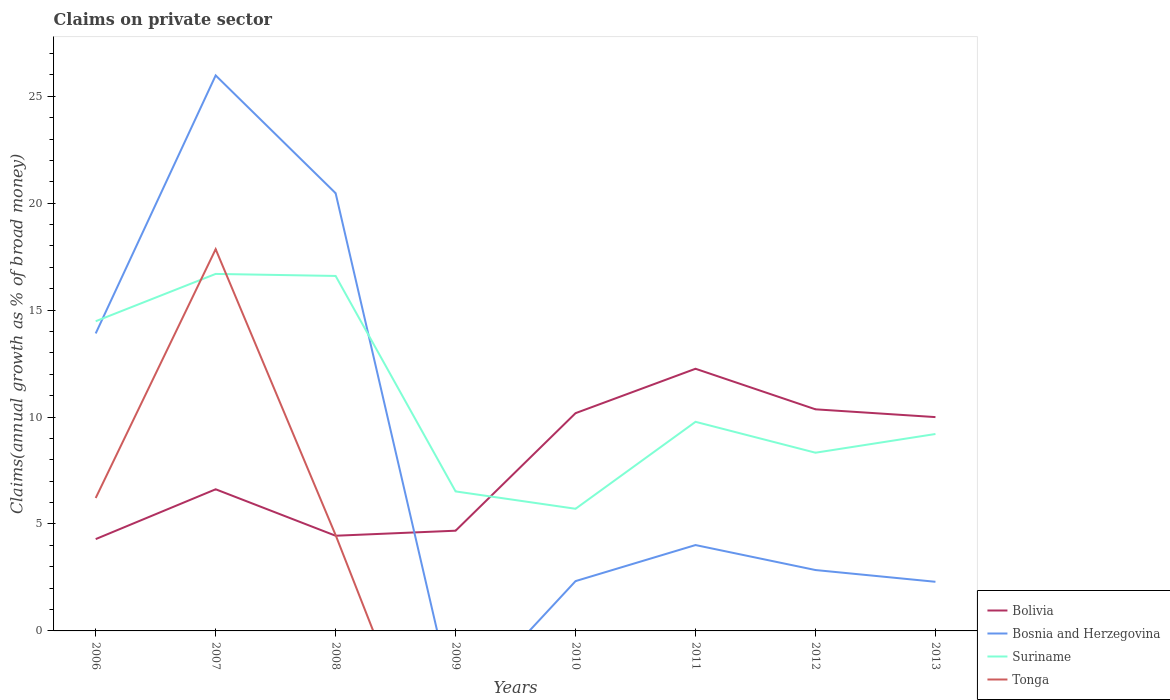How many different coloured lines are there?
Your response must be concise. 4. Is the number of lines equal to the number of legend labels?
Give a very brief answer. No. Across all years, what is the maximum percentage of broad money claimed on private sector in Tonga?
Keep it short and to the point. 0. What is the total percentage of broad money claimed on private sector in Bosnia and Herzegovina in the graph?
Give a very brief answer. 18.17. What is the difference between the highest and the second highest percentage of broad money claimed on private sector in Bosnia and Herzegovina?
Ensure brevity in your answer.  25.98. How many lines are there?
Make the answer very short. 4. Does the graph contain any zero values?
Make the answer very short. Yes. Does the graph contain grids?
Make the answer very short. No. How many legend labels are there?
Make the answer very short. 4. What is the title of the graph?
Make the answer very short. Claims on private sector. What is the label or title of the X-axis?
Offer a very short reply. Years. What is the label or title of the Y-axis?
Your answer should be compact. Claims(annual growth as % of broad money). What is the Claims(annual growth as % of broad money) in Bolivia in 2006?
Make the answer very short. 4.29. What is the Claims(annual growth as % of broad money) of Bosnia and Herzegovina in 2006?
Ensure brevity in your answer.  13.91. What is the Claims(annual growth as % of broad money) of Suriname in 2006?
Make the answer very short. 14.48. What is the Claims(annual growth as % of broad money) in Tonga in 2006?
Give a very brief answer. 6.22. What is the Claims(annual growth as % of broad money) in Bolivia in 2007?
Make the answer very short. 6.62. What is the Claims(annual growth as % of broad money) of Bosnia and Herzegovina in 2007?
Ensure brevity in your answer.  25.98. What is the Claims(annual growth as % of broad money) in Suriname in 2007?
Offer a very short reply. 16.69. What is the Claims(annual growth as % of broad money) in Tonga in 2007?
Offer a terse response. 17.85. What is the Claims(annual growth as % of broad money) in Bolivia in 2008?
Give a very brief answer. 4.45. What is the Claims(annual growth as % of broad money) in Bosnia and Herzegovina in 2008?
Give a very brief answer. 20.47. What is the Claims(annual growth as % of broad money) in Suriname in 2008?
Provide a succinct answer. 16.6. What is the Claims(annual growth as % of broad money) of Tonga in 2008?
Ensure brevity in your answer.  4.48. What is the Claims(annual growth as % of broad money) in Bolivia in 2009?
Make the answer very short. 4.69. What is the Claims(annual growth as % of broad money) of Suriname in 2009?
Give a very brief answer. 6.52. What is the Claims(annual growth as % of broad money) of Tonga in 2009?
Keep it short and to the point. 0. What is the Claims(annual growth as % of broad money) of Bolivia in 2010?
Provide a succinct answer. 10.18. What is the Claims(annual growth as % of broad money) in Bosnia and Herzegovina in 2010?
Your answer should be very brief. 2.33. What is the Claims(annual growth as % of broad money) in Suriname in 2010?
Provide a succinct answer. 5.71. What is the Claims(annual growth as % of broad money) in Tonga in 2010?
Provide a succinct answer. 0. What is the Claims(annual growth as % of broad money) in Bolivia in 2011?
Ensure brevity in your answer.  12.26. What is the Claims(annual growth as % of broad money) in Bosnia and Herzegovina in 2011?
Give a very brief answer. 4.02. What is the Claims(annual growth as % of broad money) in Suriname in 2011?
Ensure brevity in your answer.  9.78. What is the Claims(annual growth as % of broad money) in Tonga in 2011?
Provide a short and direct response. 0. What is the Claims(annual growth as % of broad money) in Bolivia in 2012?
Your response must be concise. 10.36. What is the Claims(annual growth as % of broad money) in Bosnia and Herzegovina in 2012?
Make the answer very short. 2.85. What is the Claims(annual growth as % of broad money) in Suriname in 2012?
Provide a succinct answer. 8.33. What is the Claims(annual growth as % of broad money) in Tonga in 2012?
Your response must be concise. 0. What is the Claims(annual growth as % of broad money) of Bolivia in 2013?
Your answer should be very brief. 10. What is the Claims(annual growth as % of broad money) in Bosnia and Herzegovina in 2013?
Offer a very short reply. 2.3. What is the Claims(annual growth as % of broad money) of Suriname in 2013?
Offer a very short reply. 9.21. What is the Claims(annual growth as % of broad money) in Tonga in 2013?
Keep it short and to the point. 0. Across all years, what is the maximum Claims(annual growth as % of broad money) of Bolivia?
Keep it short and to the point. 12.26. Across all years, what is the maximum Claims(annual growth as % of broad money) of Bosnia and Herzegovina?
Give a very brief answer. 25.98. Across all years, what is the maximum Claims(annual growth as % of broad money) in Suriname?
Provide a short and direct response. 16.69. Across all years, what is the maximum Claims(annual growth as % of broad money) of Tonga?
Give a very brief answer. 17.85. Across all years, what is the minimum Claims(annual growth as % of broad money) of Bolivia?
Give a very brief answer. 4.29. Across all years, what is the minimum Claims(annual growth as % of broad money) in Bosnia and Herzegovina?
Keep it short and to the point. 0. Across all years, what is the minimum Claims(annual growth as % of broad money) of Suriname?
Offer a very short reply. 5.71. Across all years, what is the minimum Claims(annual growth as % of broad money) in Tonga?
Offer a very short reply. 0. What is the total Claims(annual growth as % of broad money) of Bolivia in the graph?
Keep it short and to the point. 62.86. What is the total Claims(annual growth as % of broad money) of Bosnia and Herzegovina in the graph?
Provide a succinct answer. 71.84. What is the total Claims(annual growth as % of broad money) in Suriname in the graph?
Give a very brief answer. 87.33. What is the total Claims(annual growth as % of broad money) in Tonga in the graph?
Give a very brief answer. 28.55. What is the difference between the Claims(annual growth as % of broad money) of Bolivia in 2006 and that in 2007?
Ensure brevity in your answer.  -2.33. What is the difference between the Claims(annual growth as % of broad money) of Bosnia and Herzegovina in 2006 and that in 2007?
Offer a very short reply. -12.06. What is the difference between the Claims(annual growth as % of broad money) of Suriname in 2006 and that in 2007?
Your answer should be very brief. -2.21. What is the difference between the Claims(annual growth as % of broad money) in Tonga in 2006 and that in 2007?
Make the answer very short. -11.63. What is the difference between the Claims(annual growth as % of broad money) in Bolivia in 2006 and that in 2008?
Provide a short and direct response. -0.16. What is the difference between the Claims(annual growth as % of broad money) of Bosnia and Herzegovina in 2006 and that in 2008?
Ensure brevity in your answer.  -6.56. What is the difference between the Claims(annual growth as % of broad money) of Suriname in 2006 and that in 2008?
Keep it short and to the point. -2.12. What is the difference between the Claims(annual growth as % of broad money) in Tonga in 2006 and that in 2008?
Your response must be concise. 1.73. What is the difference between the Claims(annual growth as % of broad money) of Bolivia in 2006 and that in 2009?
Ensure brevity in your answer.  -0.39. What is the difference between the Claims(annual growth as % of broad money) in Suriname in 2006 and that in 2009?
Provide a short and direct response. 7.96. What is the difference between the Claims(annual growth as % of broad money) of Bolivia in 2006 and that in 2010?
Your response must be concise. -5.89. What is the difference between the Claims(annual growth as % of broad money) of Bosnia and Herzegovina in 2006 and that in 2010?
Ensure brevity in your answer.  11.58. What is the difference between the Claims(annual growth as % of broad money) in Suriname in 2006 and that in 2010?
Ensure brevity in your answer.  8.77. What is the difference between the Claims(annual growth as % of broad money) in Bolivia in 2006 and that in 2011?
Ensure brevity in your answer.  -7.96. What is the difference between the Claims(annual growth as % of broad money) of Bosnia and Herzegovina in 2006 and that in 2011?
Give a very brief answer. 9.9. What is the difference between the Claims(annual growth as % of broad money) of Suriname in 2006 and that in 2011?
Ensure brevity in your answer.  4.7. What is the difference between the Claims(annual growth as % of broad money) in Bolivia in 2006 and that in 2012?
Ensure brevity in your answer.  -6.07. What is the difference between the Claims(annual growth as % of broad money) in Bosnia and Herzegovina in 2006 and that in 2012?
Give a very brief answer. 11.06. What is the difference between the Claims(annual growth as % of broad money) in Suriname in 2006 and that in 2012?
Make the answer very short. 6.15. What is the difference between the Claims(annual growth as % of broad money) in Bolivia in 2006 and that in 2013?
Your answer should be compact. -5.7. What is the difference between the Claims(annual growth as % of broad money) of Bosnia and Herzegovina in 2006 and that in 2013?
Your answer should be compact. 11.61. What is the difference between the Claims(annual growth as % of broad money) in Suriname in 2006 and that in 2013?
Your answer should be very brief. 5.27. What is the difference between the Claims(annual growth as % of broad money) in Bolivia in 2007 and that in 2008?
Your response must be concise. 2.17. What is the difference between the Claims(annual growth as % of broad money) of Bosnia and Herzegovina in 2007 and that in 2008?
Your answer should be compact. 5.51. What is the difference between the Claims(annual growth as % of broad money) of Suriname in 2007 and that in 2008?
Your response must be concise. 0.1. What is the difference between the Claims(annual growth as % of broad money) in Tonga in 2007 and that in 2008?
Offer a very short reply. 13.37. What is the difference between the Claims(annual growth as % of broad money) in Bolivia in 2007 and that in 2009?
Your response must be concise. 1.94. What is the difference between the Claims(annual growth as % of broad money) of Suriname in 2007 and that in 2009?
Give a very brief answer. 10.17. What is the difference between the Claims(annual growth as % of broad money) of Bolivia in 2007 and that in 2010?
Provide a short and direct response. -3.56. What is the difference between the Claims(annual growth as % of broad money) of Bosnia and Herzegovina in 2007 and that in 2010?
Provide a short and direct response. 23.65. What is the difference between the Claims(annual growth as % of broad money) of Suriname in 2007 and that in 2010?
Your answer should be compact. 10.98. What is the difference between the Claims(annual growth as % of broad money) in Bolivia in 2007 and that in 2011?
Make the answer very short. -5.64. What is the difference between the Claims(annual growth as % of broad money) of Bosnia and Herzegovina in 2007 and that in 2011?
Ensure brevity in your answer.  21.96. What is the difference between the Claims(annual growth as % of broad money) in Suriname in 2007 and that in 2011?
Keep it short and to the point. 6.92. What is the difference between the Claims(annual growth as % of broad money) of Bolivia in 2007 and that in 2012?
Offer a terse response. -3.74. What is the difference between the Claims(annual growth as % of broad money) of Bosnia and Herzegovina in 2007 and that in 2012?
Offer a terse response. 23.13. What is the difference between the Claims(annual growth as % of broad money) of Suriname in 2007 and that in 2012?
Provide a short and direct response. 8.36. What is the difference between the Claims(annual growth as % of broad money) in Bolivia in 2007 and that in 2013?
Your response must be concise. -3.38. What is the difference between the Claims(annual growth as % of broad money) in Bosnia and Herzegovina in 2007 and that in 2013?
Keep it short and to the point. 23.68. What is the difference between the Claims(annual growth as % of broad money) in Suriname in 2007 and that in 2013?
Make the answer very short. 7.49. What is the difference between the Claims(annual growth as % of broad money) of Bolivia in 2008 and that in 2009?
Keep it short and to the point. -0.24. What is the difference between the Claims(annual growth as % of broad money) in Suriname in 2008 and that in 2009?
Offer a very short reply. 10.08. What is the difference between the Claims(annual growth as % of broad money) of Bolivia in 2008 and that in 2010?
Ensure brevity in your answer.  -5.73. What is the difference between the Claims(annual growth as % of broad money) in Bosnia and Herzegovina in 2008 and that in 2010?
Provide a short and direct response. 18.14. What is the difference between the Claims(annual growth as % of broad money) in Suriname in 2008 and that in 2010?
Provide a succinct answer. 10.89. What is the difference between the Claims(annual growth as % of broad money) in Bolivia in 2008 and that in 2011?
Your answer should be compact. -7.81. What is the difference between the Claims(annual growth as % of broad money) of Bosnia and Herzegovina in 2008 and that in 2011?
Provide a short and direct response. 16.45. What is the difference between the Claims(annual growth as % of broad money) of Suriname in 2008 and that in 2011?
Give a very brief answer. 6.82. What is the difference between the Claims(annual growth as % of broad money) in Bolivia in 2008 and that in 2012?
Your response must be concise. -5.91. What is the difference between the Claims(annual growth as % of broad money) of Bosnia and Herzegovina in 2008 and that in 2012?
Ensure brevity in your answer.  17.62. What is the difference between the Claims(annual growth as % of broad money) of Suriname in 2008 and that in 2012?
Offer a terse response. 8.27. What is the difference between the Claims(annual growth as % of broad money) in Bolivia in 2008 and that in 2013?
Provide a short and direct response. -5.55. What is the difference between the Claims(annual growth as % of broad money) of Bosnia and Herzegovina in 2008 and that in 2013?
Keep it short and to the point. 18.17. What is the difference between the Claims(annual growth as % of broad money) of Suriname in 2008 and that in 2013?
Provide a succinct answer. 7.39. What is the difference between the Claims(annual growth as % of broad money) of Bolivia in 2009 and that in 2010?
Ensure brevity in your answer.  -5.5. What is the difference between the Claims(annual growth as % of broad money) of Suriname in 2009 and that in 2010?
Keep it short and to the point. 0.81. What is the difference between the Claims(annual growth as % of broad money) of Bolivia in 2009 and that in 2011?
Offer a terse response. -7.57. What is the difference between the Claims(annual growth as % of broad money) of Suriname in 2009 and that in 2011?
Your answer should be very brief. -3.25. What is the difference between the Claims(annual growth as % of broad money) of Bolivia in 2009 and that in 2012?
Your response must be concise. -5.68. What is the difference between the Claims(annual growth as % of broad money) of Suriname in 2009 and that in 2012?
Give a very brief answer. -1.81. What is the difference between the Claims(annual growth as % of broad money) in Bolivia in 2009 and that in 2013?
Your response must be concise. -5.31. What is the difference between the Claims(annual growth as % of broad money) of Suriname in 2009 and that in 2013?
Your response must be concise. -2.68. What is the difference between the Claims(annual growth as % of broad money) of Bolivia in 2010 and that in 2011?
Make the answer very short. -2.08. What is the difference between the Claims(annual growth as % of broad money) of Bosnia and Herzegovina in 2010 and that in 2011?
Provide a succinct answer. -1.69. What is the difference between the Claims(annual growth as % of broad money) in Suriname in 2010 and that in 2011?
Give a very brief answer. -4.07. What is the difference between the Claims(annual growth as % of broad money) of Bolivia in 2010 and that in 2012?
Provide a short and direct response. -0.18. What is the difference between the Claims(annual growth as % of broad money) in Bosnia and Herzegovina in 2010 and that in 2012?
Ensure brevity in your answer.  -0.52. What is the difference between the Claims(annual growth as % of broad money) in Suriname in 2010 and that in 2012?
Provide a succinct answer. -2.62. What is the difference between the Claims(annual growth as % of broad money) of Bolivia in 2010 and that in 2013?
Provide a succinct answer. 0.18. What is the difference between the Claims(annual growth as % of broad money) in Bosnia and Herzegovina in 2010 and that in 2013?
Give a very brief answer. 0.03. What is the difference between the Claims(annual growth as % of broad money) of Suriname in 2010 and that in 2013?
Offer a terse response. -3.5. What is the difference between the Claims(annual growth as % of broad money) of Bolivia in 2011 and that in 2012?
Your response must be concise. 1.9. What is the difference between the Claims(annual growth as % of broad money) of Bosnia and Herzegovina in 2011 and that in 2012?
Give a very brief answer. 1.17. What is the difference between the Claims(annual growth as % of broad money) of Suriname in 2011 and that in 2012?
Your answer should be very brief. 1.44. What is the difference between the Claims(annual growth as % of broad money) of Bolivia in 2011 and that in 2013?
Provide a short and direct response. 2.26. What is the difference between the Claims(annual growth as % of broad money) of Bosnia and Herzegovina in 2011 and that in 2013?
Provide a succinct answer. 1.72. What is the difference between the Claims(annual growth as % of broad money) of Suriname in 2011 and that in 2013?
Your answer should be very brief. 0.57. What is the difference between the Claims(annual growth as % of broad money) in Bolivia in 2012 and that in 2013?
Keep it short and to the point. 0.36. What is the difference between the Claims(annual growth as % of broad money) in Bosnia and Herzegovina in 2012 and that in 2013?
Make the answer very short. 0.55. What is the difference between the Claims(annual growth as % of broad money) of Suriname in 2012 and that in 2013?
Provide a succinct answer. -0.87. What is the difference between the Claims(annual growth as % of broad money) of Bolivia in 2006 and the Claims(annual growth as % of broad money) of Bosnia and Herzegovina in 2007?
Provide a short and direct response. -21.68. What is the difference between the Claims(annual growth as % of broad money) of Bolivia in 2006 and the Claims(annual growth as % of broad money) of Suriname in 2007?
Your answer should be very brief. -12.4. What is the difference between the Claims(annual growth as % of broad money) of Bolivia in 2006 and the Claims(annual growth as % of broad money) of Tonga in 2007?
Provide a short and direct response. -13.56. What is the difference between the Claims(annual growth as % of broad money) in Bosnia and Herzegovina in 2006 and the Claims(annual growth as % of broad money) in Suriname in 2007?
Keep it short and to the point. -2.78. What is the difference between the Claims(annual growth as % of broad money) of Bosnia and Herzegovina in 2006 and the Claims(annual growth as % of broad money) of Tonga in 2007?
Ensure brevity in your answer.  -3.94. What is the difference between the Claims(annual growth as % of broad money) in Suriname in 2006 and the Claims(annual growth as % of broad money) in Tonga in 2007?
Keep it short and to the point. -3.37. What is the difference between the Claims(annual growth as % of broad money) in Bolivia in 2006 and the Claims(annual growth as % of broad money) in Bosnia and Herzegovina in 2008?
Provide a short and direct response. -16.17. What is the difference between the Claims(annual growth as % of broad money) of Bolivia in 2006 and the Claims(annual growth as % of broad money) of Suriname in 2008?
Provide a short and direct response. -12.3. What is the difference between the Claims(annual growth as % of broad money) of Bolivia in 2006 and the Claims(annual growth as % of broad money) of Tonga in 2008?
Keep it short and to the point. -0.19. What is the difference between the Claims(annual growth as % of broad money) in Bosnia and Herzegovina in 2006 and the Claims(annual growth as % of broad money) in Suriname in 2008?
Provide a succinct answer. -2.69. What is the difference between the Claims(annual growth as % of broad money) of Bosnia and Herzegovina in 2006 and the Claims(annual growth as % of broad money) of Tonga in 2008?
Your answer should be compact. 9.43. What is the difference between the Claims(annual growth as % of broad money) in Suriname in 2006 and the Claims(annual growth as % of broad money) in Tonga in 2008?
Provide a succinct answer. 10. What is the difference between the Claims(annual growth as % of broad money) of Bolivia in 2006 and the Claims(annual growth as % of broad money) of Suriname in 2009?
Keep it short and to the point. -2.23. What is the difference between the Claims(annual growth as % of broad money) in Bosnia and Herzegovina in 2006 and the Claims(annual growth as % of broad money) in Suriname in 2009?
Make the answer very short. 7.39. What is the difference between the Claims(annual growth as % of broad money) in Bolivia in 2006 and the Claims(annual growth as % of broad money) in Bosnia and Herzegovina in 2010?
Provide a succinct answer. 1.96. What is the difference between the Claims(annual growth as % of broad money) in Bolivia in 2006 and the Claims(annual growth as % of broad money) in Suriname in 2010?
Offer a very short reply. -1.42. What is the difference between the Claims(annual growth as % of broad money) of Bosnia and Herzegovina in 2006 and the Claims(annual growth as % of broad money) of Suriname in 2010?
Ensure brevity in your answer.  8.2. What is the difference between the Claims(annual growth as % of broad money) in Bolivia in 2006 and the Claims(annual growth as % of broad money) in Bosnia and Herzegovina in 2011?
Ensure brevity in your answer.  0.28. What is the difference between the Claims(annual growth as % of broad money) of Bolivia in 2006 and the Claims(annual growth as % of broad money) of Suriname in 2011?
Provide a short and direct response. -5.48. What is the difference between the Claims(annual growth as % of broad money) in Bosnia and Herzegovina in 2006 and the Claims(annual growth as % of broad money) in Suriname in 2011?
Ensure brevity in your answer.  4.13. What is the difference between the Claims(annual growth as % of broad money) of Bolivia in 2006 and the Claims(annual growth as % of broad money) of Bosnia and Herzegovina in 2012?
Ensure brevity in your answer.  1.45. What is the difference between the Claims(annual growth as % of broad money) of Bolivia in 2006 and the Claims(annual growth as % of broad money) of Suriname in 2012?
Give a very brief answer. -4.04. What is the difference between the Claims(annual growth as % of broad money) in Bosnia and Herzegovina in 2006 and the Claims(annual growth as % of broad money) in Suriname in 2012?
Give a very brief answer. 5.58. What is the difference between the Claims(annual growth as % of broad money) of Bolivia in 2006 and the Claims(annual growth as % of broad money) of Bosnia and Herzegovina in 2013?
Offer a terse response. 2. What is the difference between the Claims(annual growth as % of broad money) of Bolivia in 2006 and the Claims(annual growth as % of broad money) of Suriname in 2013?
Your answer should be compact. -4.91. What is the difference between the Claims(annual growth as % of broad money) in Bosnia and Herzegovina in 2006 and the Claims(annual growth as % of broad money) in Suriname in 2013?
Ensure brevity in your answer.  4.7. What is the difference between the Claims(annual growth as % of broad money) of Bolivia in 2007 and the Claims(annual growth as % of broad money) of Bosnia and Herzegovina in 2008?
Offer a very short reply. -13.84. What is the difference between the Claims(annual growth as % of broad money) in Bolivia in 2007 and the Claims(annual growth as % of broad money) in Suriname in 2008?
Your answer should be compact. -9.98. What is the difference between the Claims(annual growth as % of broad money) of Bolivia in 2007 and the Claims(annual growth as % of broad money) of Tonga in 2008?
Offer a terse response. 2.14. What is the difference between the Claims(annual growth as % of broad money) in Bosnia and Herzegovina in 2007 and the Claims(annual growth as % of broad money) in Suriname in 2008?
Your response must be concise. 9.38. What is the difference between the Claims(annual growth as % of broad money) of Bosnia and Herzegovina in 2007 and the Claims(annual growth as % of broad money) of Tonga in 2008?
Provide a succinct answer. 21.49. What is the difference between the Claims(annual growth as % of broad money) in Suriname in 2007 and the Claims(annual growth as % of broad money) in Tonga in 2008?
Give a very brief answer. 12.21. What is the difference between the Claims(annual growth as % of broad money) of Bolivia in 2007 and the Claims(annual growth as % of broad money) of Suriname in 2009?
Ensure brevity in your answer.  0.1. What is the difference between the Claims(annual growth as % of broad money) of Bosnia and Herzegovina in 2007 and the Claims(annual growth as % of broad money) of Suriname in 2009?
Your answer should be compact. 19.45. What is the difference between the Claims(annual growth as % of broad money) in Bolivia in 2007 and the Claims(annual growth as % of broad money) in Bosnia and Herzegovina in 2010?
Offer a very short reply. 4.29. What is the difference between the Claims(annual growth as % of broad money) of Bolivia in 2007 and the Claims(annual growth as % of broad money) of Suriname in 2010?
Provide a succinct answer. 0.91. What is the difference between the Claims(annual growth as % of broad money) of Bosnia and Herzegovina in 2007 and the Claims(annual growth as % of broad money) of Suriname in 2010?
Offer a very short reply. 20.26. What is the difference between the Claims(annual growth as % of broad money) in Bolivia in 2007 and the Claims(annual growth as % of broad money) in Bosnia and Herzegovina in 2011?
Provide a short and direct response. 2.61. What is the difference between the Claims(annual growth as % of broad money) of Bolivia in 2007 and the Claims(annual growth as % of broad money) of Suriname in 2011?
Make the answer very short. -3.15. What is the difference between the Claims(annual growth as % of broad money) in Bosnia and Herzegovina in 2007 and the Claims(annual growth as % of broad money) in Suriname in 2011?
Ensure brevity in your answer.  16.2. What is the difference between the Claims(annual growth as % of broad money) of Bolivia in 2007 and the Claims(annual growth as % of broad money) of Bosnia and Herzegovina in 2012?
Provide a succinct answer. 3.78. What is the difference between the Claims(annual growth as % of broad money) of Bolivia in 2007 and the Claims(annual growth as % of broad money) of Suriname in 2012?
Your answer should be very brief. -1.71. What is the difference between the Claims(annual growth as % of broad money) of Bosnia and Herzegovina in 2007 and the Claims(annual growth as % of broad money) of Suriname in 2012?
Your answer should be very brief. 17.64. What is the difference between the Claims(annual growth as % of broad money) of Bolivia in 2007 and the Claims(annual growth as % of broad money) of Bosnia and Herzegovina in 2013?
Provide a succinct answer. 4.33. What is the difference between the Claims(annual growth as % of broad money) of Bolivia in 2007 and the Claims(annual growth as % of broad money) of Suriname in 2013?
Your response must be concise. -2.58. What is the difference between the Claims(annual growth as % of broad money) in Bosnia and Herzegovina in 2007 and the Claims(annual growth as % of broad money) in Suriname in 2013?
Make the answer very short. 16.77. What is the difference between the Claims(annual growth as % of broad money) in Bolivia in 2008 and the Claims(annual growth as % of broad money) in Suriname in 2009?
Keep it short and to the point. -2.07. What is the difference between the Claims(annual growth as % of broad money) in Bosnia and Herzegovina in 2008 and the Claims(annual growth as % of broad money) in Suriname in 2009?
Keep it short and to the point. 13.94. What is the difference between the Claims(annual growth as % of broad money) of Bolivia in 2008 and the Claims(annual growth as % of broad money) of Bosnia and Herzegovina in 2010?
Keep it short and to the point. 2.12. What is the difference between the Claims(annual growth as % of broad money) in Bolivia in 2008 and the Claims(annual growth as % of broad money) in Suriname in 2010?
Offer a terse response. -1.26. What is the difference between the Claims(annual growth as % of broad money) of Bosnia and Herzegovina in 2008 and the Claims(annual growth as % of broad money) of Suriname in 2010?
Ensure brevity in your answer.  14.76. What is the difference between the Claims(annual growth as % of broad money) in Bolivia in 2008 and the Claims(annual growth as % of broad money) in Bosnia and Herzegovina in 2011?
Your response must be concise. 0.44. What is the difference between the Claims(annual growth as % of broad money) in Bolivia in 2008 and the Claims(annual growth as % of broad money) in Suriname in 2011?
Make the answer very short. -5.33. What is the difference between the Claims(annual growth as % of broad money) of Bosnia and Herzegovina in 2008 and the Claims(annual growth as % of broad money) of Suriname in 2011?
Ensure brevity in your answer.  10.69. What is the difference between the Claims(annual growth as % of broad money) in Bolivia in 2008 and the Claims(annual growth as % of broad money) in Bosnia and Herzegovina in 2012?
Make the answer very short. 1.6. What is the difference between the Claims(annual growth as % of broad money) in Bolivia in 2008 and the Claims(annual growth as % of broad money) in Suriname in 2012?
Offer a very short reply. -3.88. What is the difference between the Claims(annual growth as % of broad money) of Bosnia and Herzegovina in 2008 and the Claims(annual growth as % of broad money) of Suriname in 2012?
Make the answer very short. 12.13. What is the difference between the Claims(annual growth as % of broad money) of Bolivia in 2008 and the Claims(annual growth as % of broad money) of Bosnia and Herzegovina in 2013?
Provide a succinct answer. 2.15. What is the difference between the Claims(annual growth as % of broad money) in Bolivia in 2008 and the Claims(annual growth as % of broad money) in Suriname in 2013?
Your response must be concise. -4.76. What is the difference between the Claims(annual growth as % of broad money) in Bosnia and Herzegovina in 2008 and the Claims(annual growth as % of broad money) in Suriname in 2013?
Your answer should be compact. 11.26. What is the difference between the Claims(annual growth as % of broad money) of Bolivia in 2009 and the Claims(annual growth as % of broad money) of Bosnia and Herzegovina in 2010?
Offer a very short reply. 2.36. What is the difference between the Claims(annual growth as % of broad money) in Bolivia in 2009 and the Claims(annual growth as % of broad money) in Suriname in 2010?
Give a very brief answer. -1.03. What is the difference between the Claims(annual growth as % of broad money) of Bolivia in 2009 and the Claims(annual growth as % of broad money) of Bosnia and Herzegovina in 2011?
Give a very brief answer. 0.67. What is the difference between the Claims(annual growth as % of broad money) in Bolivia in 2009 and the Claims(annual growth as % of broad money) in Suriname in 2011?
Give a very brief answer. -5.09. What is the difference between the Claims(annual growth as % of broad money) of Bolivia in 2009 and the Claims(annual growth as % of broad money) of Bosnia and Herzegovina in 2012?
Provide a succinct answer. 1.84. What is the difference between the Claims(annual growth as % of broad money) of Bolivia in 2009 and the Claims(annual growth as % of broad money) of Suriname in 2012?
Make the answer very short. -3.65. What is the difference between the Claims(annual growth as % of broad money) in Bolivia in 2009 and the Claims(annual growth as % of broad money) in Bosnia and Herzegovina in 2013?
Provide a short and direct response. 2.39. What is the difference between the Claims(annual growth as % of broad money) in Bolivia in 2009 and the Claims(annual growth as % of broad money) in Suriname in 2013?
Provide a short and direct response. -4.52. What is the difference between the Claims(annual growth as % of broad money) in Bolivia in 2010 and the Claims(annual growth as % of broad money) in Bosnia and Herzegovina in 2011?
Provide a short and direct response. 6.17. What is the difference between the Claims(annual growth as % of broad money) of Bolivia in 2010 and the Claims(annual growth as % of broad money) of Suriname in 2011?
Your response must be concise. 0.4. What is the difference between the Claims(annual growth as % of broad money) of Bosnia and Herzegovina in 2010 and the Claims(annual growth as % of broad money) of Suriname in 2011?
Provide a succinct answer. -7.45. What is the difference between the Claims(annual growth as % of broad money) of Bolivia in 2010 and the Claims(annual growth as % of broad money) of Bosnia and Herzegovina in 2012?
Offer a very short reply. 7.34. What is the difference between the Claims(annual growth as % of broad money) of Bolivia in 2010 and the Claims(annual growth as % of broad money) of Suriname in 2012?
Keep it short and to the point. 1.85. What is the difference between the Claims(annual growth as % of broad money) in Bosnia and Herzegovina in 2010 and the Claims(annual growth as % of broad money) in Suriname in 2012?
Offer a very short reply. -6. What is the difference between the Claims(annual growth as % of broad money) of Bolivia in 2010 and the Claims(annual growth as % of broad money) of Bosnia and Herzegovina in 2013?
Your response must be concise. 7.89. What is the difference between the Claims(annual growth as % of broad money) of Bolivia in 2010 and the Claims(annual growth as % of broad money) of Suriname in 2013?
Keep it short and to the point. 0.97. What is the difference between the Claims(annual growth as % of broad money) of Bosnia and Herzegovina in 2010 and the Claims(annual growth as % of broad money) of Suriname in 2013?
Offer a terse response. -6.88. What is the difference between the Claims(annual growth as % of broad money) of Bolivia in 2011 and the Claims(annual growth as % of broad money) of Bosnia and Herzegovina in 2012?
Your answer should be compact. 9.41. What is the difference between the Claims(annual growth as % of broad money) in Bolivia in 2011 and the Claims(annual growth as % of broad money) in Suriname in 2012?
Your response must be concise. 3.93. What is the difference between the Claims(annual growth as % of broad money) of Bosnia and Herzegovina in 2011 and the Claims(annual growth as % of broad money) of Suriname in 2012?
Provide a succinct answer. -4.32. What is the difference between the Claims(annual growth as % of broad money) in Bolivia in 2011 and the Claims(annual growth as % of broad money) in Bosnia and Herzegovina in 2013?
Keep it short and to the point. 9.96. What is the difference between the Claims(annual growth as % of broad money) of Bolivia in 2011 and the Claims(annual growth as % of broad money) of Suriname in 2013?
Your answer should be very brief. 3.05. What is the difference between the Claims(annual growth as % of broad money) in Bosnia and Herzegovina in 2011 and the Claims(annual growth as % of broad money) in Suriname in 2013?
Offer a terse response. -5.19. What is the difference between the Claims(annual growth as % of broad money) of Bolivia in 2012 and the Claims(annual growth as % of broad money) of Bosnia and Herzegovina in 2013?
Offer a very short reply. 8.06. What is the difference between the Claims(annual growth as % of broad money) of Bolivia in 2012 and the Claims(annual growth as % of broad money) of Suriname in 2013?
Offer a very short reply. 1.15. What is the difference between the Claims(annual growth as % of broad money) in Bosnia and Herzegovina in 2012 and the Claims(annual growth as % of broad money) in Suriname in 2013?
Make the answer very short. -6.36. What is the average Claims(annual growth as % of broad money) of Bolivia per year?
Your answer should be compact. 7.86. What is the average Claims(annual growth as % of broad money) of Bosnia and Herzegovina per year?
Make the answer very short. 8.98. What is the average Claims(annual growth as % of broad money) of Suriname per year?
Give a very brief answer. 10.92. What is the average Claims(annual growth as % of broad money) of Tonga per year?
Keep it short and to the point. 3.57. In the year 2006, what is the difference between the Claims(annual growth as % of broad money) of Bolivia and Claims(annual growth as % of broad money) of Bosnia and Herzegovina?
Provide a short and direct response. -9.62. In the year 2006, what is the difference between the Claims(annual growth as % of broad money) in Bolivia and Claims(annual growth as % of broad money) in Suriname?
Offer a very short reply. -10.19. In the year 2006, what is the difference between the Claims(annual growth as % of broad money) in Bolivia and Claims(annual growth as % of broad money) in Tonga?
Keep it short and to the point. -1.92. In the year 2006, what is the difference between the Claims(annual growth as % of broad money) in Bosnia and Herzegovina and Claims(annual growth as % of broad money) in Suriname?
Provide a short and direct response. -0.57. In the year 2006, what is the difference between the Claims(annual growth as % of broad money) of Bosnia and Herzegovina and Claims(annual growth as % of broad money) of Tonga?
Give a very brief answer. 7.7. In the year 2006, what is the difference between the Claims(annual growth as % of broad money) in Suriname and Claims(annual growth as % of broad money) in Tonga?
Keep it short and to the point. 8.27. In the year 2007, what is the difference between the Claims(annual growth as % of broad money) of Bolivia and Claims(annual growth as % of broad money) of Bosnia and Herzegovina?
Ensure brevity in your answer.  -19.35. In the year 2007, what is the difference between the Claims(annual growth as % of broad money) in Bolivia and Claims(annual growth as % of broad money) in Suriname?
Offer a terse response. -10.07. In the year 2007, what is the difference between the Claims(annual growth as % of broad money) in Bolivia and Claims(annual growth as % of broad money) in Tonga?
Your response must be concise. -11.23. In the year 2007, what is the difference between the Claims(annual growth as % of broad money) of Bosnia and Herzegovina and Claims(annual growth as % of broad money) of Suriname?
Offer a terse response. 9.28. In the year 2007, what is the difference between the Claims(annual growth as % of broad money) in Bosnia and Herzegovina and Claims(annual growth as % of broad money) in Tonga?
Your answer should be very brief. 8.13. In the year 2007, what is the difference between the Claims(annual growth as % of broad money) of Suriname and Claims(annual growth as % of broad money) of Tonga?
Provide a succinct answer. -1.16. In the year 2008, what is the difference between the Claims(annual growth as % of broad money) in Bolivia and Claims(annual growth as % of broad money) in Bosnia and Herzegovina?
Provide a succinct answer. -16.02. In the year 2008, what is the difference between the Claims(annual growth as % of broad money) in Bolivia and Claims(annual growth as % of broad money) in Suriname?
Make the answer very short. -12.15. In the year 2008, what is the difference between the Claims(annual growth as % of broad money) in Bolivia and Claims(annual growth as % of broad money) in Tonga?
Make the answer very short. -0.03. In the year 2008, what is the difference between the Claims(annual growth as % of broad money) in Bosnia and Herzegovina and Claims(annual growth as % of broad money) in Suriname?
Make the answer very short. 3.87. In the year 2008, what is the difference between the Claims(annual growth as % of broad money) in Bosnia and Herzegovina and Claims(annual growth as % of broad money) in Tonga?
Offer a very short reply. 15.99. In the year 2008, what is the difference between the Claims(annual growth as % of broad money) in Suriname and Claims(annual growth as % of broad money) in Tonga?
Your answer should be very brief. 12.12. In the year 2009, what is the difference between the Claims(annual growth as % of broad money) in Bolivia and Claims(annual growth as % of broad money) in Suriname?
Make the answer very short. -1.84. In the year 2010, what is the difference between the Claims(annual growth as % of broad money) of Bolivia and Claims(annual growth as % of broad money) of Bosnia and Herzegovina?
Give a very brief answer. 7.85. In the year 2010, what is the difference between the Claims(annual growth as % of broad money) of Bolivia and Claims(annual growth as % of broad money) of Suriname?
Keep it short and to the point. 4.47. In the year 2010, what is the difference between the Claims(annual growth as % of broad money) in Bosnia and Herzegovina and Claims(annual growth as % of broad money) in Suriname?
Offer a terse response. -3.38. In the year 2011, what is the difference between the Claims(annual growth as % of broad money) of Bolivia and Claims(annual growth as % of broad money) of Bosnia and Herzegovina?
Your answer should be very brief. 8.24. In the year 2011, what is the difference between the Claims(annual growth as % of broad money) in Bolivia and Claims(annual growth as % of broad money) in Suriname?
Provide a short and direct response. 2.48. In the year 2011, what is the difference between the Claims(annual growth as % of broad money) of Bosnia and Herzegovina and Claims(annual growth as % of broad money) of Suriname?
Offer a very short reply. -5.76. In the year 2012, what is the difference between the Claims(annual growth as % of broad money) in Bolivia and Claims(annual growth as % of broad money) in Bosnia and Herzegovina?
Your answer should be very brief. 7.52. In the year 2012, what is the difference between the Claims(annual growth as % of broad money) in Bolivia and Claims(annual growth as % of broad money) in Suriname?
Your response must be concise. 2.03. In the year 2012, what is the difference between the Claims(annual growth as % of broad money) of Bosnia and Herzegovina and Claims(annual growth as % of broad money) of Suriname?
Offer a very short reply. -5.49. In the year 2013, what is the difference between the Claims(annual growth as % of broad money) in Bolivia and Claims(annual growth as % of broad money) in Bosnia and Herzegovina?
Offer a terse response. 7.7. In the year 2013, what is the difference between the Claims(annual growth as % of broad money) in Bolivia and Claims(annual growth as % of broad money) in Suriname?
Provide a succinct answer. 0.79. In the year 2013, what is the difference between the Claims(annual growth as % of broad money) of Bosnia and Herzegovina and Claims(annual growth as % of broad money) of Suriname?
Make the answer very short. -6.91. What is the ratio of the Claims(annual growth as % of broad money) of Bolivia in 2006 to that in 2007?
Keep it short and to the point. 0.65. What is the ratio of the Claims(annual growth as % of broad money) in Bosnia and Herzegovina in 2006 to that in 2007?
Give a very brief answer. 0.54. What is the ratio of the Claims(annual growth as % of broad money) of Suriname in 2006 to that in 2007?
Give a very brief answer. 0.87. What is the ratio of the Claims(annual growth as % of broad money) in Tonga in 2006 to that in 2007?
Provide a succinct answer. 0.35. What is the ratio of the Claims(annual growth as % of broad money) of Bolivia in 2006 to that in 2008?
Ensure brevity in your answer.  0.96. What is the ratio of the Claims(annual growth as % of broad money) of Bosnia and Herzegovina in 2006 to that in 2008?
Keep it short and to the point. 0.68. What is the ratio of the Claims(annual growth as % of broad money) of Suriname in 2006 to that in 2008?
Offer a very short reply. 0.87. What is the ratio of the Claims(annual growth as % of broad money) in Tonga in 2006 to that in 2008?
Your response must be concise. 1.39. What is the ratio of the Claims(annual growth as % of broad money) of Bolivia in 2006 to that in 2009?
Keep it short and to the point. 0.92. What is the ratio of the Claims(annual growth as % of broad money) of Suriname in 2006 to that in 2009?
Your answer should be very brief. 2.22. What is the ratio of the Claims(annual growth as % of broad money) in Bolivia in 2006 to that in 2010?
Make the answer very short. 0.42. What is the ratio of the Claims(annual growth as % of broad money) in Bosnia and Herzegovina in 2006 to that in 2010?
Keep it short and to the point. 5.97. What is the ratio of the Claims(annual growth as % of broad money) in Suriname in 2006 to that in 2010?
Provide a succinct answer. 2.54. What is the ratio of the Claims(annual growth as % of broad money) of Bolivia in 2006 to that in 2011?
Make the answer very short. 0.35. What is the ratio of the Claims(annual growth as % of broad money) of Bosnia and Herzegovina in 2006 to that in 2011?
Provide a short and direct response. 3.46. What is the ratio of the Claims(annual growth as % of broad money) in Suriname in 2006 to that in 2011?
Keep it short and to the point. 1.48. What is the ratio of the Claims(annual growth as % of broad money) in Bolivia in 2006 to that in 2012?
Provide a succinct answer. 0.41. What is the ratio of the Claims(annual growth as % of broad money) in Bosnia and Herzegovina in 2006 to that in 2012?
Provide a short and direct response. 4.89. What is the ratio of the Claims(annual growth as % of broad money) of Suriname in 2006 to that in 2012?
Your response must be concise. 1.74. What is the ratio of the Claims(annual growth as % of broad money) of Bolivia in 2006 to that in 2013?
Your answer should be compact. 0.43. What is the ratio of the Claims(annual growth as % of broad money) of Bosnia and Herzegovina in 2006 to that in 2013?
Offer a terse response. 6.05. What is the ratio of the Claims(annual growth as % of broad money) of Suriname in 2006 to that in 2013?
Provide a succinct answer. 1.57. What is the ratio of the Claims(annual growth as % of broad money) of Bolivia in 2007 to that in 2008?
Offer a very short reply. 1.49. What is the ratio of the Claims(annual growth as % of broad money) in Bosnia and Herzegovina in 2007 to that in 2008?
Offer a terse response. 1.27. What is the ratio of the Claims(annual growth as % of broad money) of Tonga in 2007 to that in 2008?
Ensure brevity in your answer.  3.98. What is the ratio of the Claims(annual growth as % of broad money) of Bolivia in 2007 to that in 2009?
Your response must be concise. 1.41. What is the ratio of the Claims(annual growth as % of broad money) in Suriname in 2007 to that in 2009?
Your answer should be very brief. 2.56. What is the ratio of the Claims(annual growth as % of broad money) in Bolivia in 2007 to that in 2010?
Provide a succinct answer. 0.65. What is the ratio of the Claims(annual growth as % of broad money) of Bosnia and Herzegovina in 2007 to that in 2010?
Your answer should be very brief. 11.15. What is the ratio of the Claims(annual growth as % of broad money) of Suriname in 2007 to that in 2010?
Make the answer very short. 2.92. What is the ratio of the Claims(annual growth as % of broad money) in Bolivia in 2007 to that in 2011?
Offer a terse response. 0.54. What is the ratio of the Claims(annual growth as % of broad money) of Bosnia and Herzegovina in 2007 to that in 2011?
Your response must be concise. 6.47. What is the ratio of the Claims(annual growth as % of broad money) of Suriname in 2007 to that in 2011?
Your answer should be very brief. 1.71. What is the ratio of the Claims(annual growth as % of broad money) of Bolivia in 2007 to that in 2012?
Offer a terse response. 0.64. What is the ratio of the Claims(annual growth as % of broad money) in Bosnia and Herzegovina in 2007 to that in 2012?
Provide a succinct answer. 9.12. What is the ratio of the Claims(annual growth as % of broad money) in Suriname in 2007 to that in 2012?
Provide a succinct answer. 2. What is the ratio of the Claims(annual growth as % of broad money) in Bolivia in 2007 to that in 2013?
Make the answer very short. 0.66. What is the ratio of the Claims(annual growth as % of broad money) of Bosnia and Herzegovina in 2007 to that in 2013?
Your answer should be very brief. 11.31. What is the ratio of the Claims(annual growth as % of broad money) of Suriname in 2007 to that in 2013?
Offer a very short reply. 1.81. What is the ratio of the Claims(annual growth as % of broad money) in Bolivia in 2008 to that in 2009?
Keep it short and to the point. 0.95. What is the ratio of the Claims(annual growth as % of broad money) of Suriname in 2008 to that in 2009?
Your answer should be very brief. 2.54. What is the ratio of the Claims(annual growth as % of broad money) in Bolivia in 2008 to that in 2010?
Offer a terse response. 0.44. What is the ratio of the Claims(annual growth as % of broad money) of Bosnia and Herzegovina in 2008 to that in 2010?
Your answer should be very brief. 8.79. What is the ratio of the Claims(annual growth as % of broad money) of Suriname in 2008 to that in 2010?
Your answer should be compact. 2.91. What is the ratio of the Claims(annual growth as % of broad money) in Bolivia in 2008 to that in 2011?
Keep it short and to the point. 0.36. What is the ratio of the Claims(annual growth as % of broad money) of Bosnia and Herzegovina in 2008 to that in 2011?
Make the answer very short. 5.1. What is the ratio of the Claims(annual growth as % of broad money) in Suriname in 2008 to that in 2011?
Your response must be concise. 1.7. What is the ratio of the Claims(annual growth as % of broad money) in Bolivia in 2008 to that in 2012?
Provide a succinct answer. 0.43. What is the ratio of the Claims(annual growth as % of broad money) of Bosnia and Herzegovina in 2008 to that in 2012?
Your response must be concise. 7.19. What is the ratio of the Claims(annual growth as % of broad money) in Suriname in 2008 to that in 2012?
Make the answer very short. 1.99. What is the ratio of the Claims(annual growth as % of broad money) of Bolivia in 2008 to that in 2013?
Make the answer very short. 0.45. What is the ratio of the Claims(annual growth as % of broad money) in Bosnia and Herzegovina in 2008 to that in 2013?
Your answer should be compact. 8.91. What is the ratio of the Claims(annual growth as % of broad money) in Suriname in 2008 to that in 2013?
Offer a very short reply. 1.8. What is the ratio of the Claims(annual growth as % of broad money) in Bolivia in 2009 to that in 2010?
Keep it short and to the point. 0.46. What is the ratio of the Claims(annual growth as % of broad money) in Suriname in 2009 to that in 2010?
Provide a short and direct response. 1.14. What is the ratio of the Claims(annual growth as % of broad money) of Bolivia in 2009 to that in 2011?
Your answer should be compact. 0.38. What is the ratio of the Claims(annual growth as % of broad money) in Suriname in 2009 to that in 2011?
Provide a succinct answer. 0.67. What is the ratio of the Claims(annual growth as % of broad money) of Bolivia in 2009 to that in 2012?
Make the answer very short. 0.45. What is the ratio of the Claims(annual growth as % of broad money) in Suriname in 2009 to that in 2012?
Provide a short and direct response. 0.78. What is the ratio of the Claims(annual growth as % of broad money) in Bolivia in 2009 to that in 2013?
Your answer should be very brief. 0.47. What is the ratio of the Claims(annual growth as % of broad money) of Suriname in 2009 to that in 2013?
Your answer should be very brief. 0.71. What is the ratio of the Claims(annual growth as % of broad money) in Bolivia in 2010 to that in 2011?
Ensure brevity in your answer.  0.83. What is the ratio of the Claims(annual growth as % of broad money) in Bosnia and Herzegovina in 2010 to that in 2011?
Your response must be concise. 0.58. What is the ratio of the Claims(annual growth as % of broad money) in Suriname in 2010 to that in 2011?
Your response must be concise. 0.58. What is the ratio of the Claims(annual growth as % of broad money) in Bolivia in 2010 to that in 2012?
Your answer should be very brief. 0.98. What is the ratio of the Claims(annual growth as % of broad money) of Bosnia and Herzegovina in 2010 to that in 2012?
Give a very brief answer. 0.82. What is the ratio of the Claims(annual growth as % of broad money) of Suriname in 2010 to that in 2012?
Offer a terse response. 0.69. What is the ratio of the Claims(annual growth as % of broad money) of Bolivia in 2010 to that in 2013?
Give a very brief answer. 1.02. What is the ratio of the Claims(annual growth as % of broad money) in Bosnia and Herzegovina in 2010 to that in 2013?
Offer a very short reply. 1.01. What is the ratio of the Claims(annual growth as % of broad money) of Suriname in 2010 to that in 2013?
Keep it short and to the point. 0.62. What is the ratio of the Claims(annual growth as % of broad money) of Bolivia in 2011 to that in 2012?
Offer a terse response. 1.18. What is the ratio of the Claims(annual growth as % of broad money) of Bosnia and Herzegovina in 2011 to that in 2012?
Keep it short and to the point. 1.41. What is the ratio of the Claims(annual growth as % of broad money) in Suriname in 2011 to that in 2012?
Offer a terse response. 1.17. What is the ratio of the Claims(annual growth as % of broad money) in Bolivia in 2011 to that in 2013?
Offer a terse response. 1.23. What is the ratio of the Claims(annual growth as % of broad money) in Bosnia and Herzegovina in 2011 to that in 2013?
Provide a succinct answer. 1.75. What is the ratio of the Claims(annual growth as % of broad money) of Suriname in 2011 to that in 2013?
Ensure brevity in your answer.  1.06. What is the ratio of the Claims(annual growth as % of broad money) of Bolivia in 2012 to that in 2013?
Your response must be concise. 1.04. What is the ratio of the Claims(annual growth as % of broad money) in Bosnia and Herzegovina in 2012 to that in 2013?
Give a very brief answer. 1.24. What is the ratio of the Claims(annual growth as % of broad money) of Suriname in 2012 to that in 2013?
Keep it short and to the point. 0.91. What is the difference between the highest and the second highest Claims(annual growth as % of broad money) in Bolivia?
Your answer should be very brief. 1.9. What is the difference between the highest and the second highest Claims(annual growth as % of broad money) in Bosnia and Herzegovina?
Keep it short and to the point. 5.51. What is the difference between the highest and the second highest Claims(annual growth as % of broad money) of Suriname?
Your response must be concise. 0.1. What is the difference between the highest and the second highest Claims(annual growth as % of broad money) of Tonga?
Your answer should be compact. 11.63. What is the difference between the highest and the lowest Claims(annual growth as % of broad money) of Bolivia?
Offer a terse response. 7.96. What is the difference between the highest and the lowest Claims(annual growth as % of broad money) in Bosnia and Herzegovina?
Ensure brevity in your answer.  25.98. What is the difference between the highest and the lowest Claims(annual growth as % of broad money) in Suriname?
Your response must be concise. 10.98. What is the difference between the highest and the lowest Claims(annual growth as % of broad money) in Tonga?
Provide a succinct answer. 17.85. 